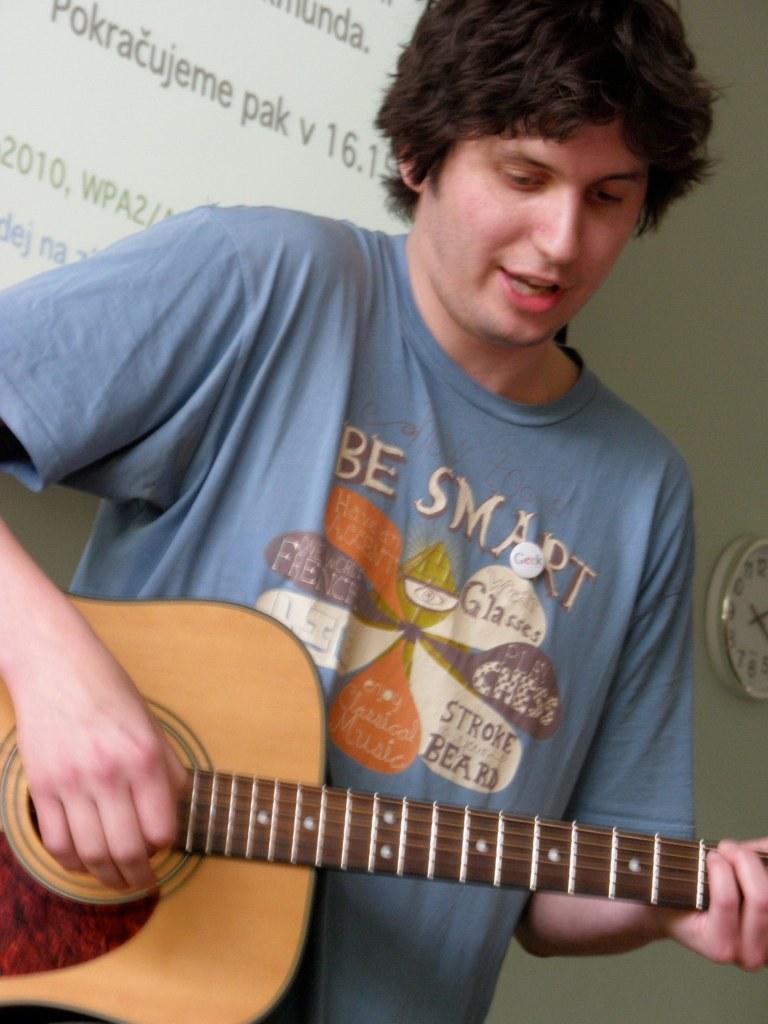Please provide a concise description of this image. In this image there is a man who is playing a guitar and in the back ground there is a clock , screen. 